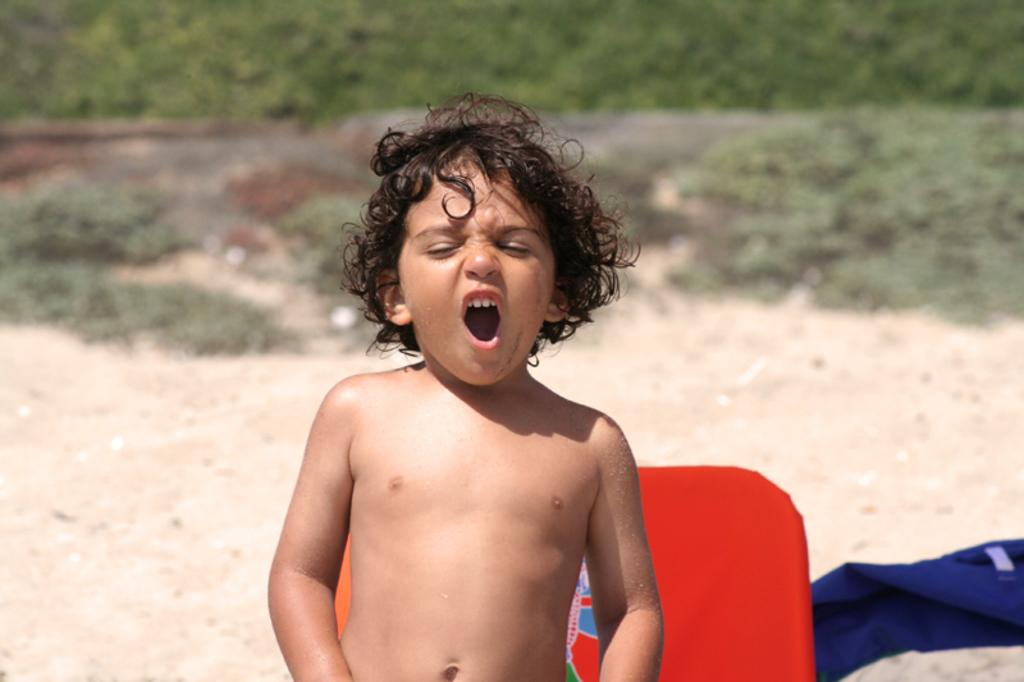Who is the main subject in the image? There is a boy in the image. What colors are present in the background of the image? There is a red object and a blue object in the background of the image. What type of vegetation can be seen in the image? There is grass visible in the image. How would you describe the quality of the image's background? The image is slightly blurry in the background. How many rakes are being used by the boy in the image? There are no rakes present in the image. What type of trains can be seen in the background of the image? There are no trains visible in the image. 